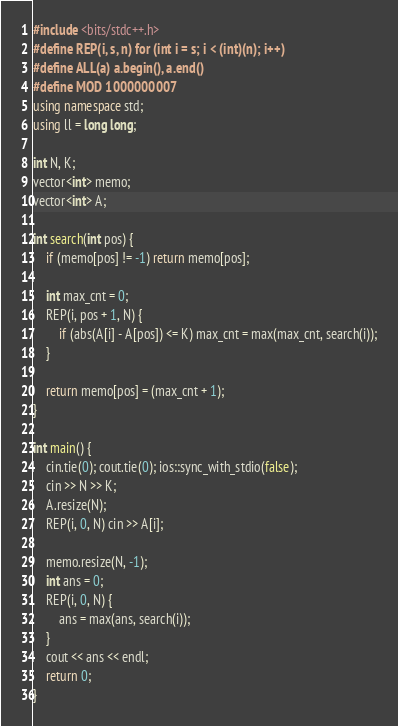Convert code to text. <code><loc_0><loc_0><loc_500><loc_500><_C++_>#include <bits/stdc++.h>
#define REP(i, s, n) for (int i = s; i < (int)(n); i++)
#define ALL(a) a.begin(), a.end()
#define MOD 1000000007
using namespace std;
using ll = long long;

int N, K;
vector<int> memo;
vector<int> A;

int search(int pos) {
    if (memo[pos] != -1) return memo[pos];

    int max_cnt = 0;
    REP(i, pos + 1, N) {
        if (abs(A[i] - A[pos]) <= K) max_cnt = max(max_cnt, search(i));
    }

    return memo[pos] = (max_cnt + 1);
}

int main() {
    cin.tie(0); cout.tie(0); ios::sync_with_stdio(false);
    cin >> N >> K;
    A.resize(N);
    REP(i, 0, N) cin >> A[i];

    memo.resize(N, -1);
    int ans = 0;
    REP(i, 0, N) {
        ans = max(ans, search(i));
    }
    cout << ans << endl;
    return 0;
}</code> 